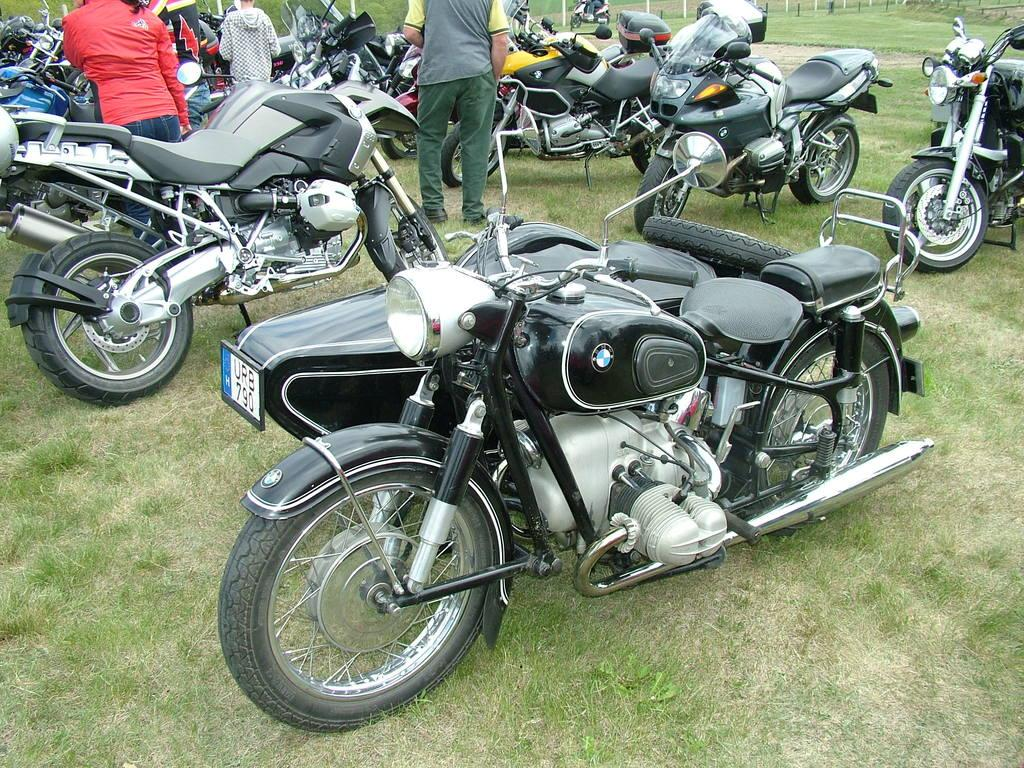How many people are in the image? There are four persons in the image. What type of terrain is visible in the image? There is grass in the image. What objects can be seen besides the people? There are bikes in the image. What is the distance between the two bikes in the image? There is no specific distance mentioned between the bikes in the image, and the image does not provide a scale for measurement. 